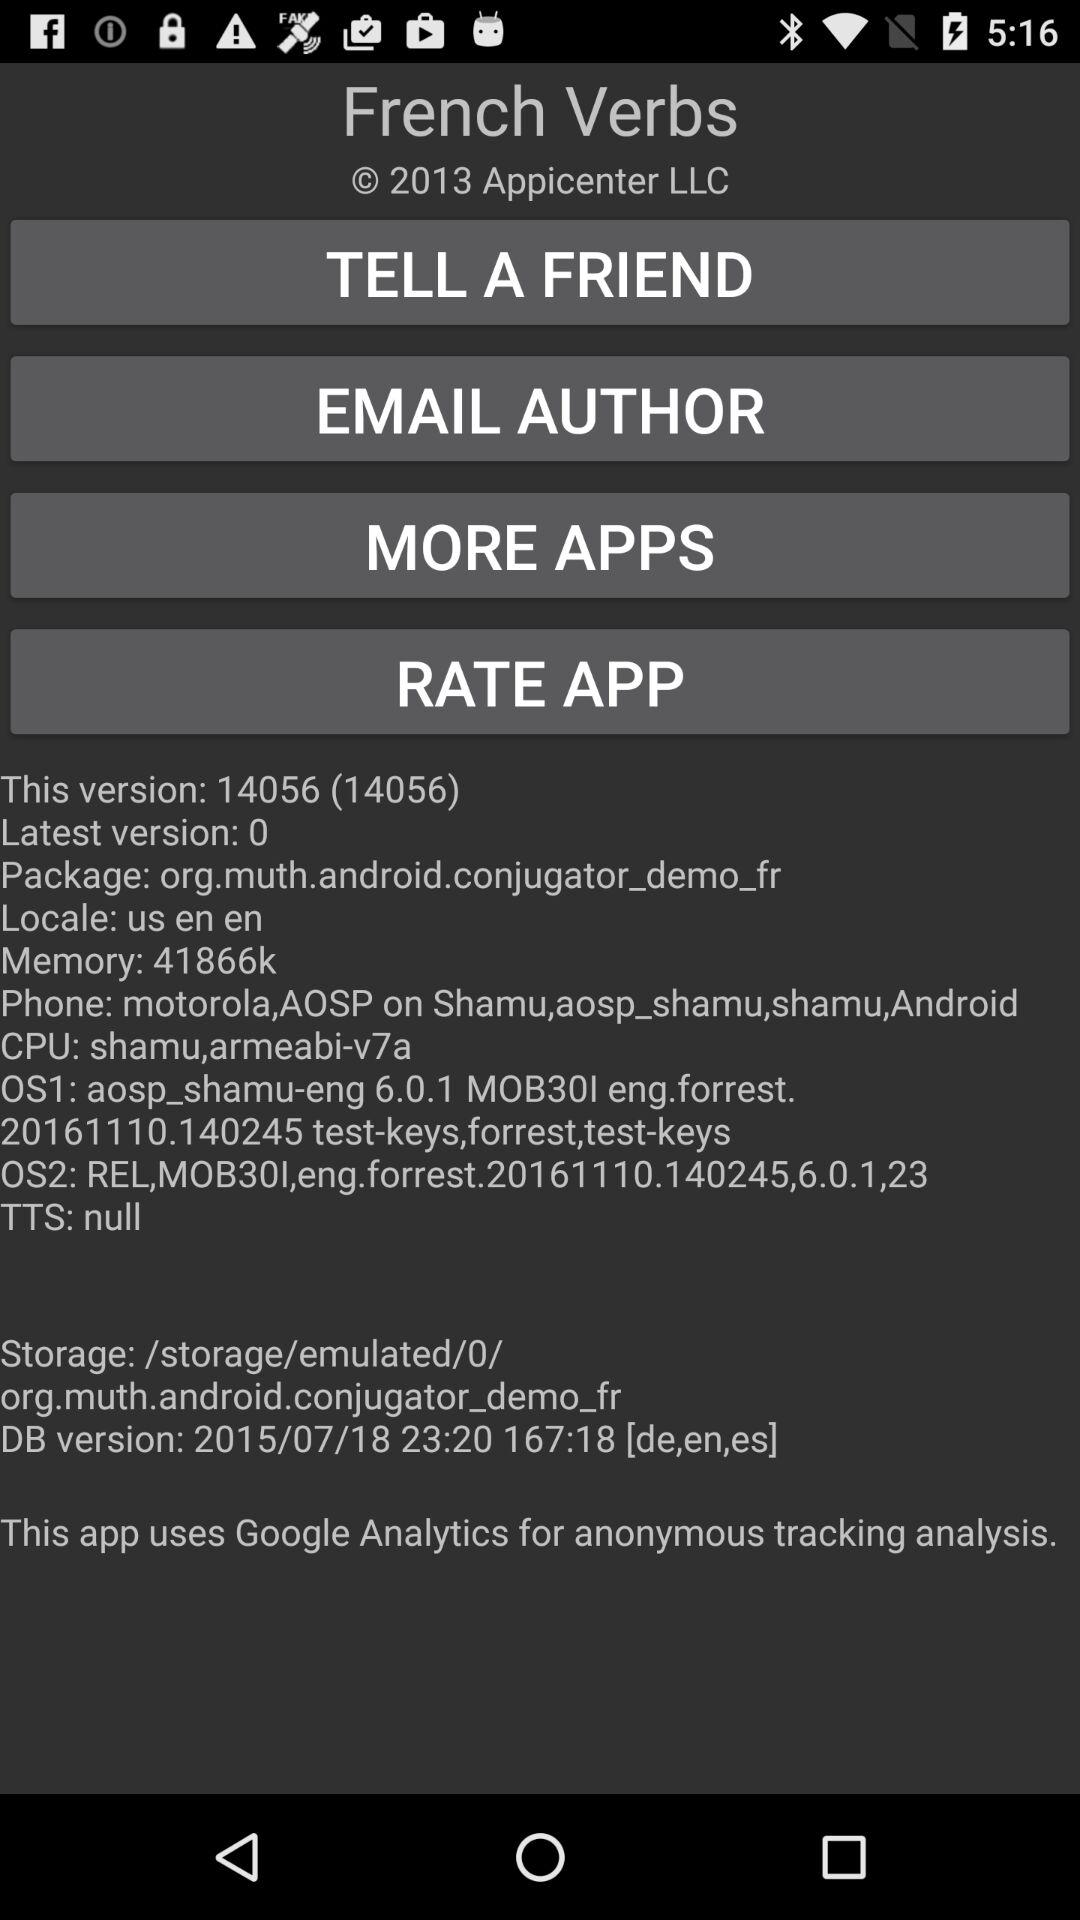What's the latest version? The latest version is zero. 